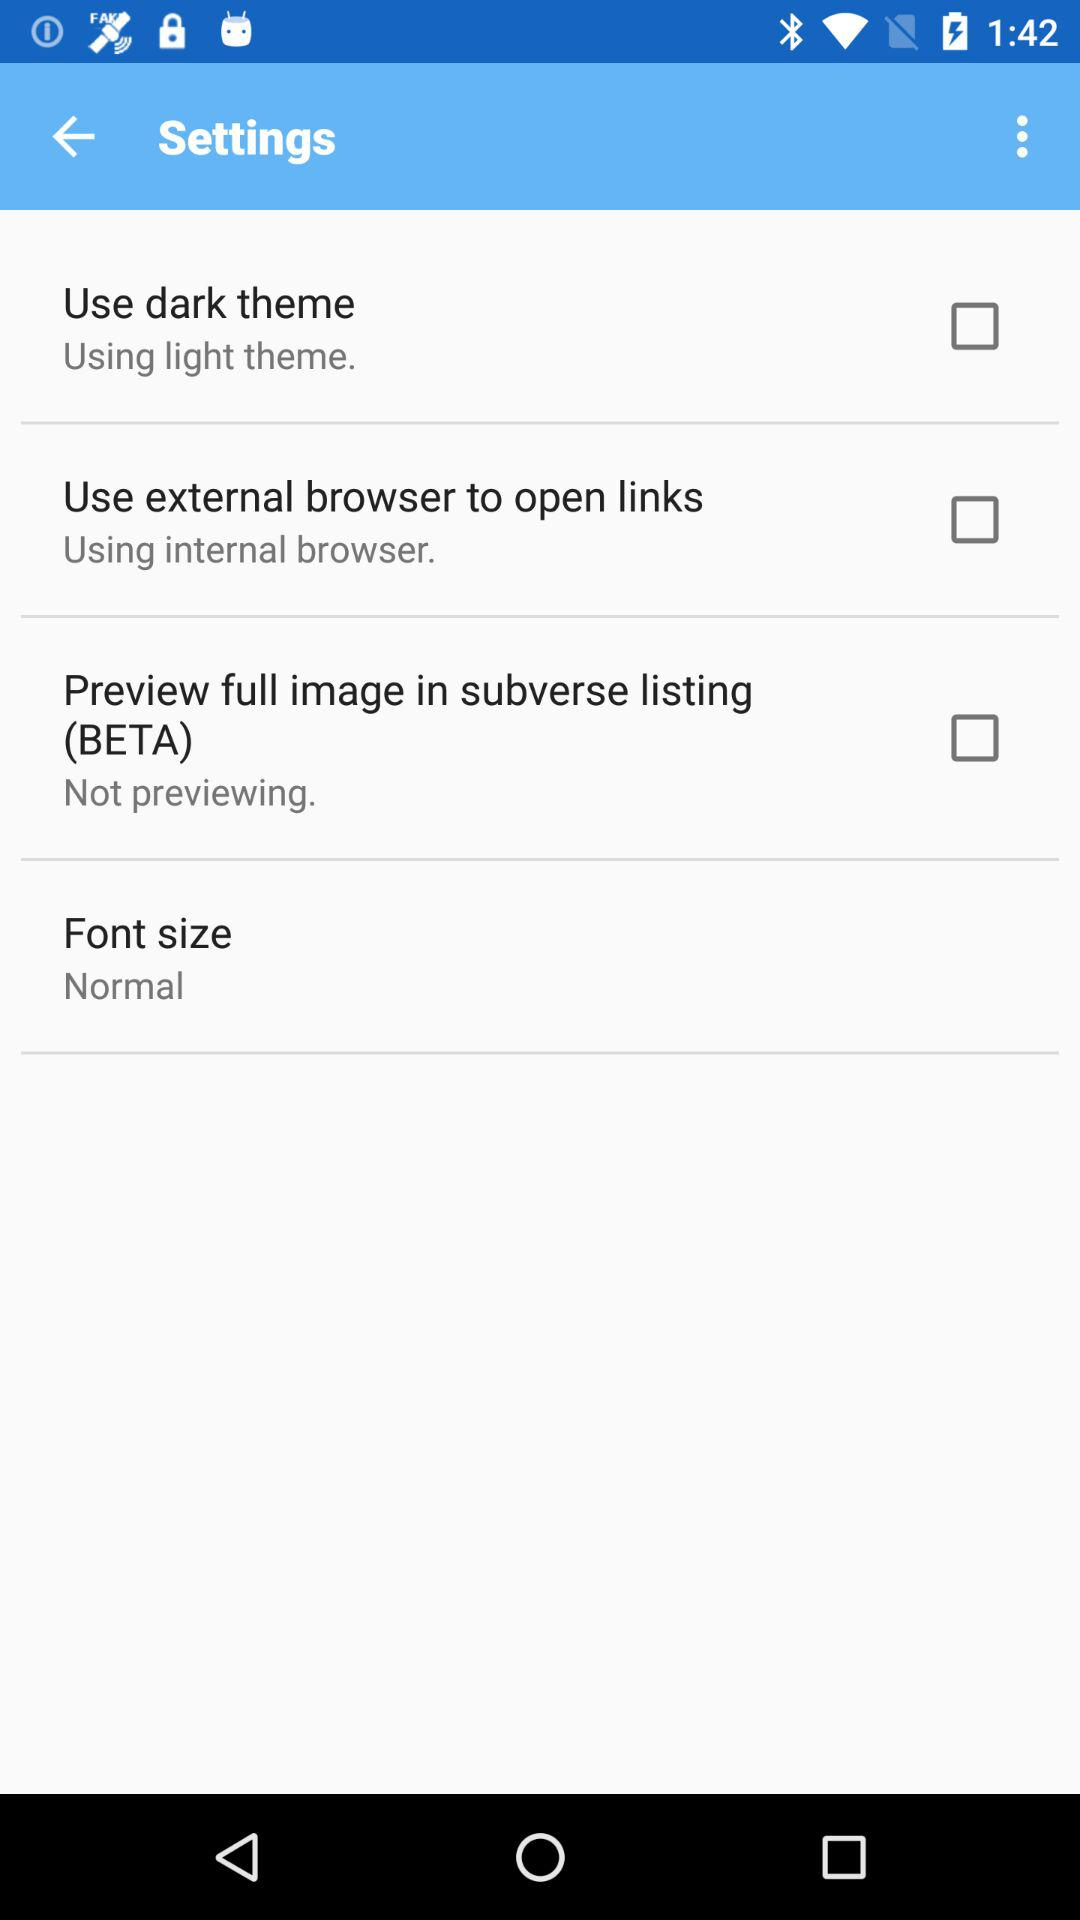What is the status of "Use external browser to open links"? The status is "off". 